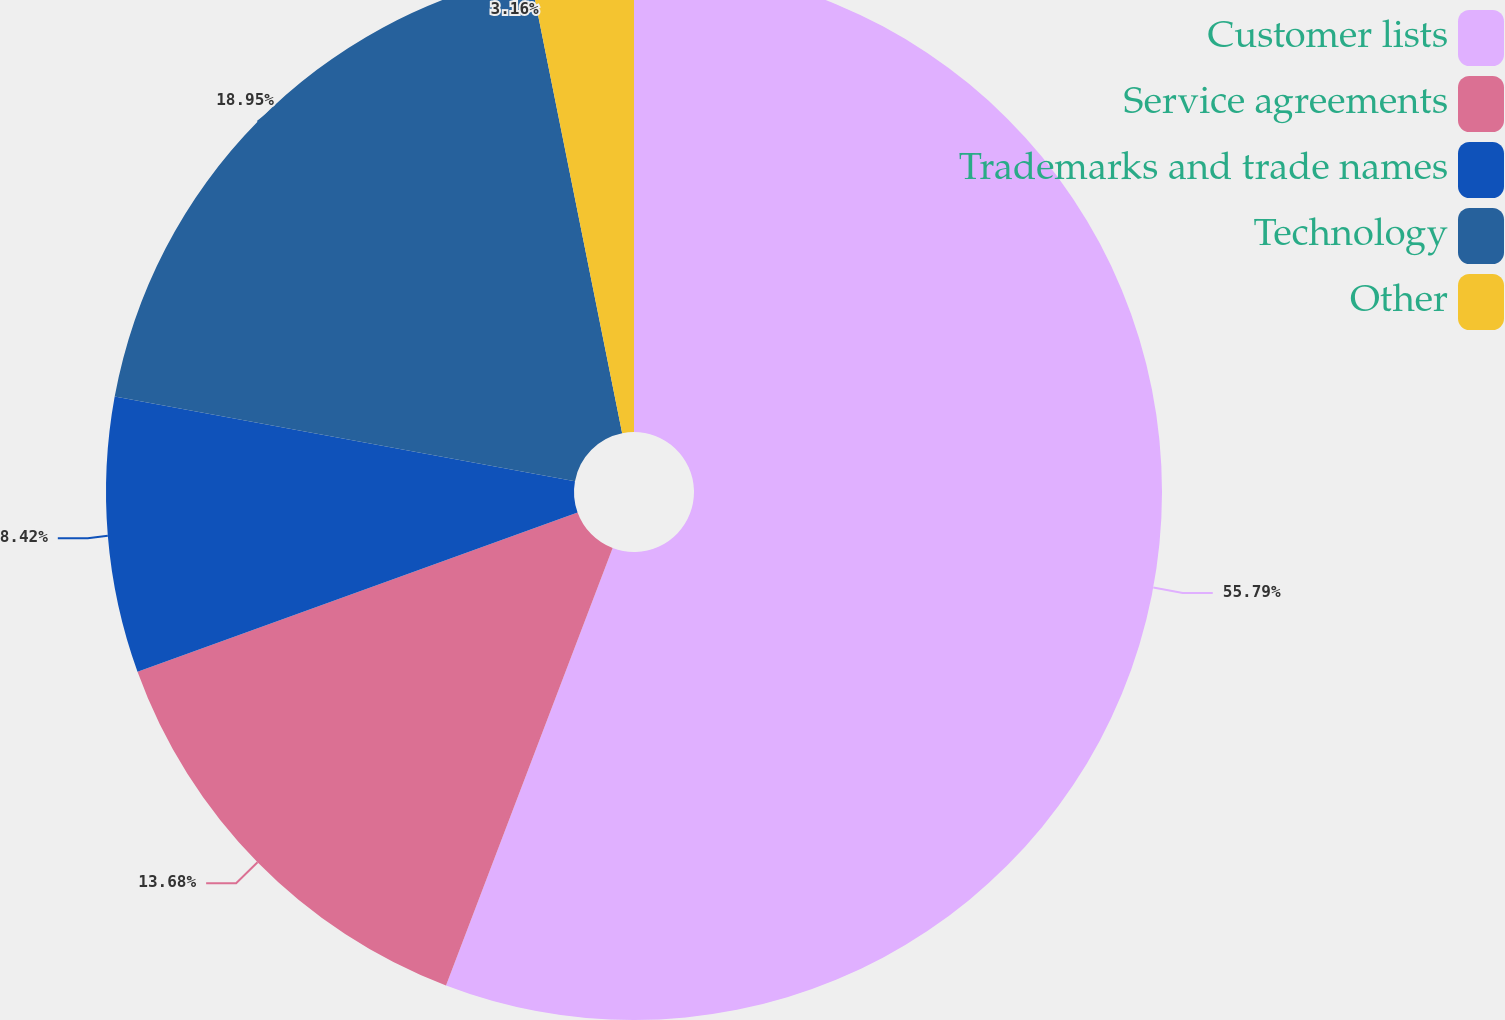Convert chart. <chart><loc_0><loc_0><loc_500><loc_500><pie_chart><fcel>Customer lists<fcel>Service agreements<fcel>Trademarks and trade names<fcel>Technology<fcel>Other<nl><fcel>55.8%<fcel>13.68%<fcel>8.42%<fcel>18.95%<fcel>3.16%<nl></chart> 